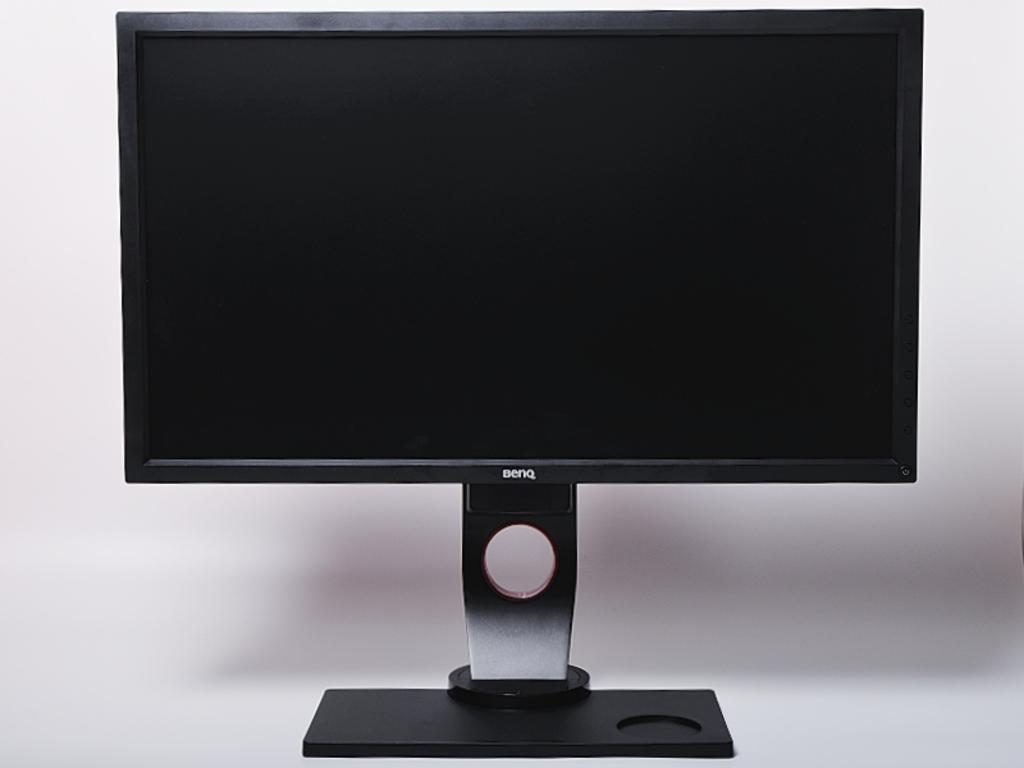<image>
Create a compact narrative representing the image presented. A BENQ TV and stand sitting on a table. 